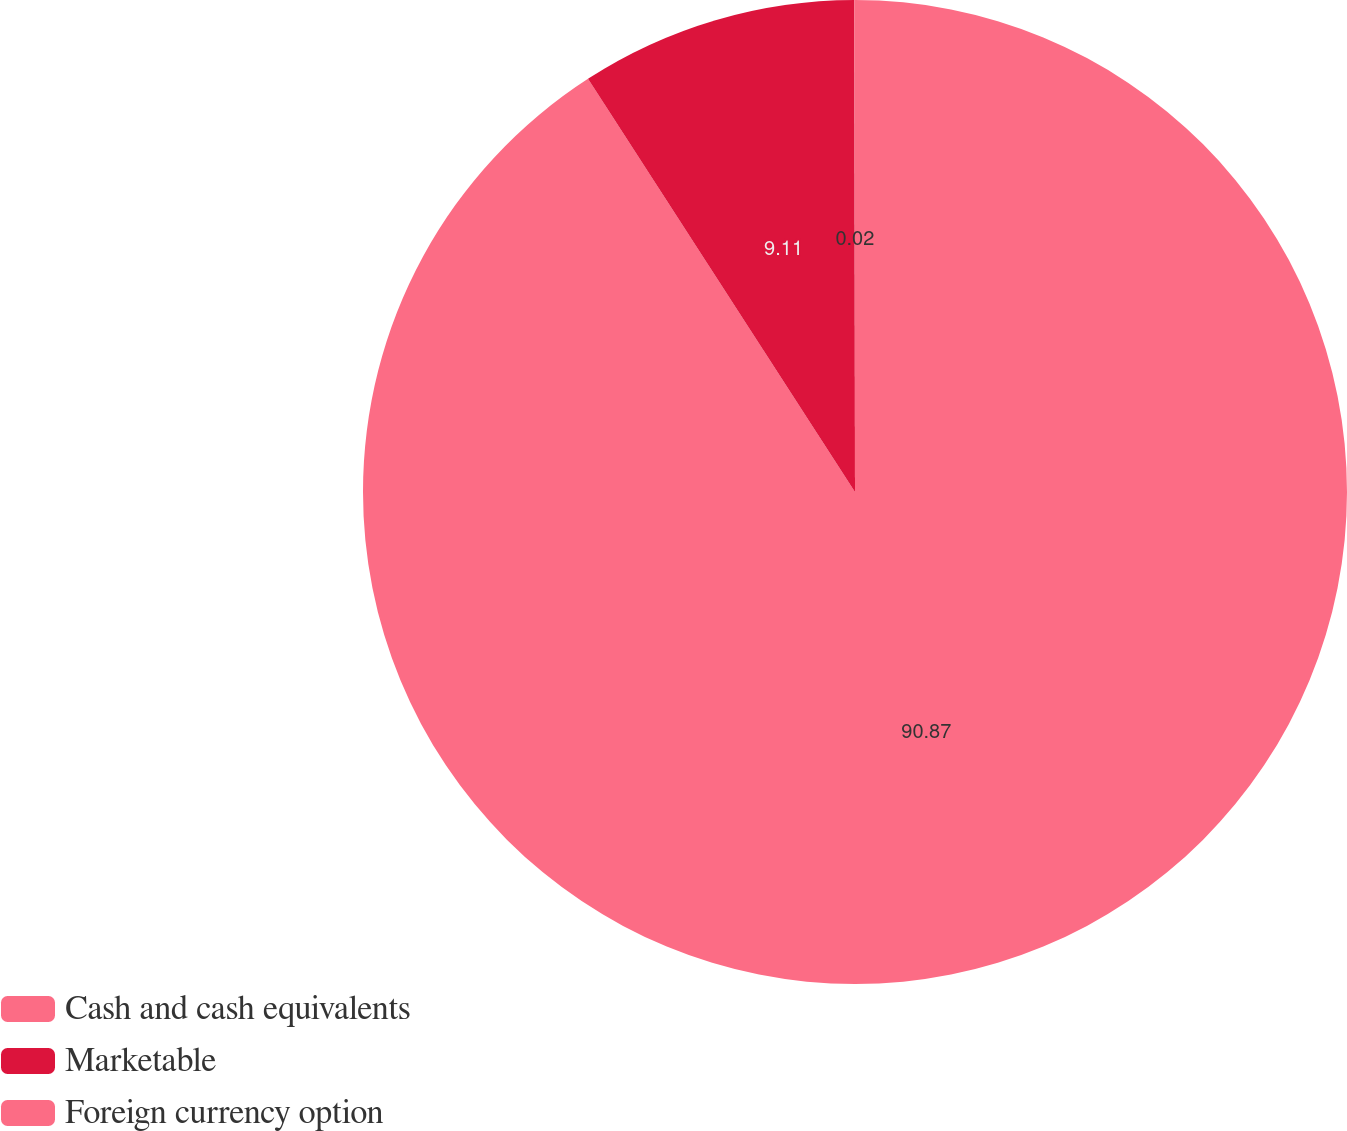<chart> <loc_0><loc_0><loc_500><loc_500><pie_chart><fcel>Cash and cash equivalents<fcel>Marketable<fcel>Foreign currency option<nl><fcel>90.87%<fcel>9.11%<fcel>0.02%<nl></chart> 